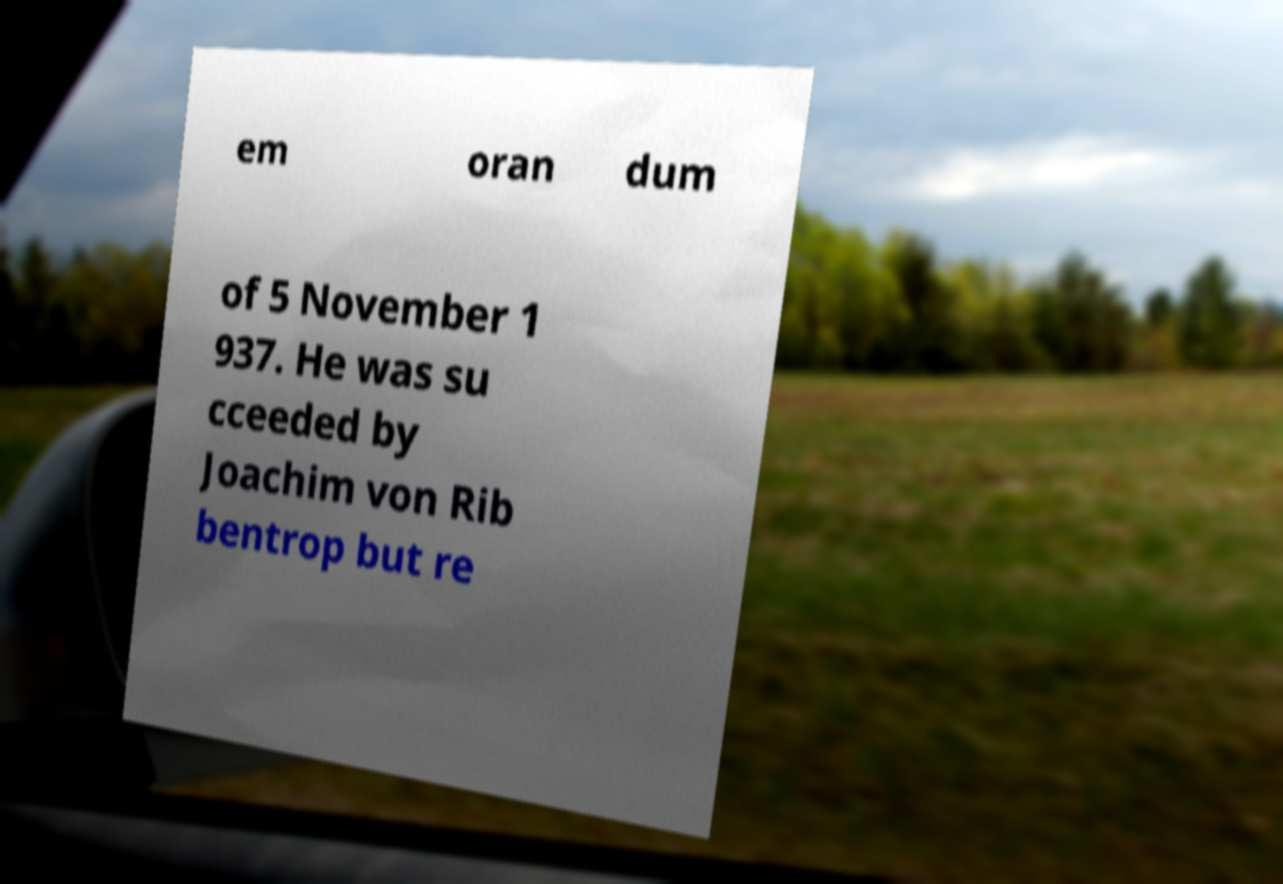Could you extract and type out the text from this image? em oran dum of 5 November 1 937. He was su cceeded by Joachim von Rib bentrop but re 